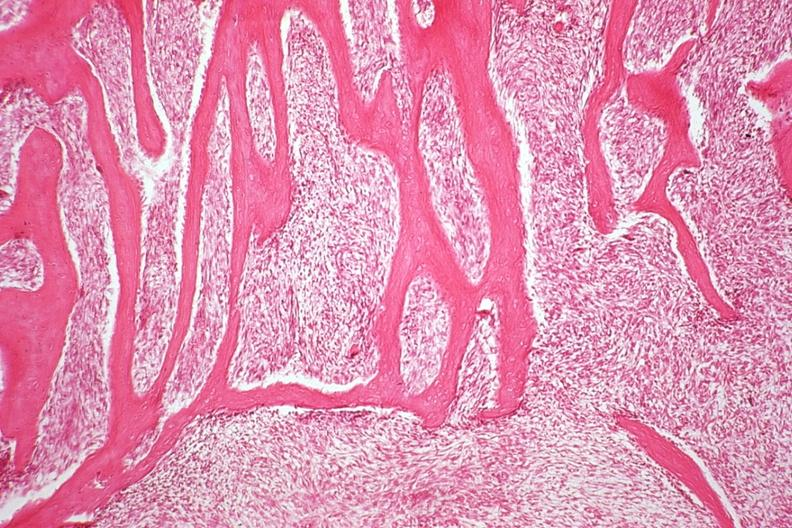what does this image show?
Answer the question using a single word or phrase. Section from tumor near codmans triangle reactive bone representing area of tumor with hair on end appearance 